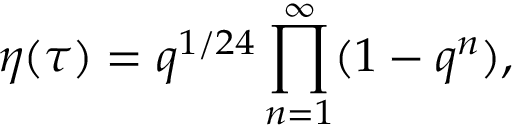Convert formula to latex. <formula><loc_0><loc_0><loc_500><loc_500>\eta ( \tau ) = q ^ { 1 / 2 4 } \prod _ { n = 1 } ^ { \infty } ( 1 - q ^ { n } ) ,</formula> 